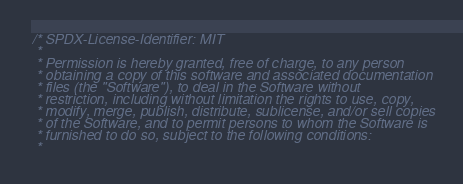<code> <loc_0><loc_0><loc_500><loc_500><_C_>/* SPDX-License-Identifier: MIT
 *
 * Permission is hereby granted, free of charge, to any person
 * obtaining a copy of this software and associated documentation
 * files (the "Software"), to deal in the Software without
 * restriction, including without limitation the rights to use, copy,
 * modify, merge, publish, distribute, sublicense, and/or sell copies
 * of the Software, and to permit persons to whom the Software is
 * furnished to do so, subject to the following conditions:
 *</code> 